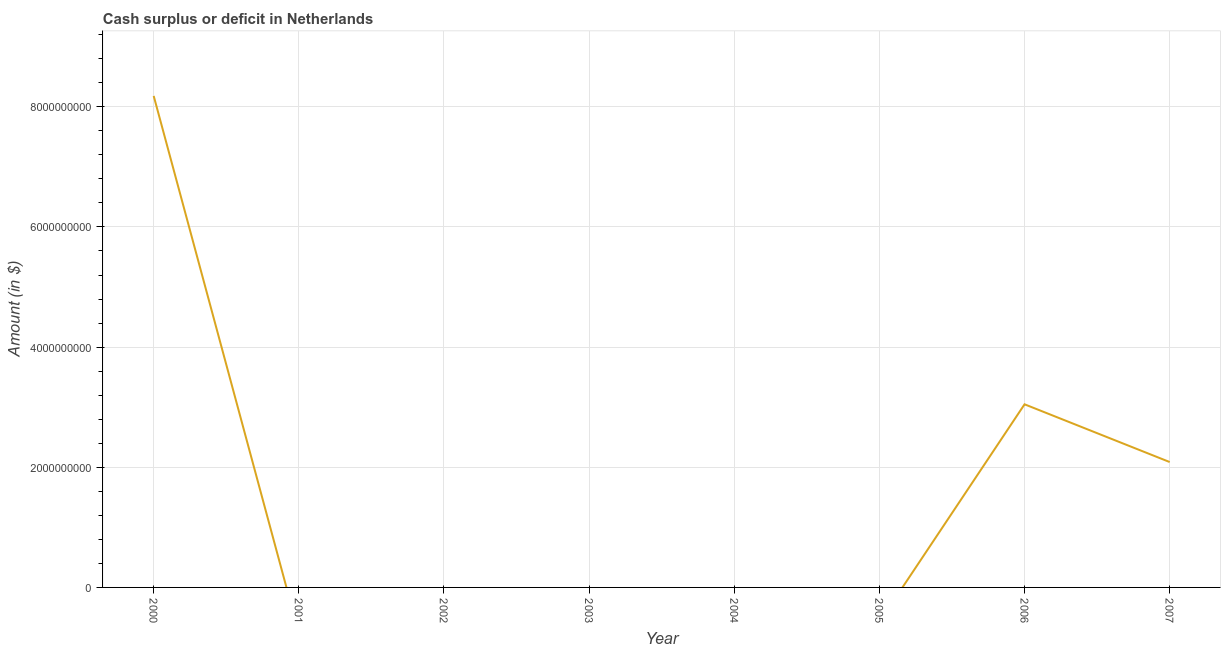Across all years, what is the maximum cash surplus or deficit?
Provide a short and direct response. 8.18e+09. In which year was the cash surplus or deficit maximum?
Offer a terse response. 2000. What is the sum of the cash surplus or deficit?
Keep it short and to the point. 1.33e+1. What is the average cash surplus or deficit per year?
Your response must be concise. 1.66e+09. In how many years, is the cash surplus or deficit greater than 400000000 $?
Your answer should be compact. 3. What is the ratio of the cash surplus or deficit in 2000 to that in 2007?
Provide a short and direct response. 3.92. Is the difference between the cash surplus or deficit in 2006 and 2007 greater than the difference between any two years?
Your answer should be very brief. No. What is the difference between the highest and the second highest cash surplus or deficit?
Make the answer very short. 5.13e+09. What is the difference between the highest and the lowest cash surplus or deficit?
Offer a terse response. 8.18e+09. Does the cash surplus or deficit monotonically increase over the years?
Make the answer very short. No. How many lines are there?
Your answer should be very brief. 1. How many years are there in the graph?
Provide a succinct answer. 8. What is the difference between two consecutive major ticks on the Y-axis?
Ensure brevity in your answer.  2.00e+09. Are the values on the major ticks of Y-axis written in scientific E-notation?
Your answer should be compact. No. What is the title of the graph?
Your answer should be compact. Cash surplus or deficit in Netherlands. What is the label or title of the Y-axis?
Give a very brief answer. Amount (in $). What is the Amount (in $) of 2000?
Provide a succinct answer. 8.18e+09. What is the Amount (in $) in 2001?
Offer a terse response. 0. What is the Amount (in $) of 2005?
Provide a short and direct response. 0. What is the Amount (in $) of 2006?
Your answer should be compact. 3.05e+09. What is the Amount (in $) in 2007?
Provide a succinct answer. 2.09e+09. What is the difference between the Amount (in $) in 2000 and 2006?
Your answer should be very brief. 5.13e+09. What is the difference between the Amount (in $) in 2000 and 2007?
Make the answer very short. 6.09e+09. What is the difference between the Amount (in $) in 2006 and 2007?
Make the answer very short. 9.61e+08. What is the ratio of the Amount (in $) in 2000 to that in 2006?
Offer a very short reply. 2.68. What is the ratio of the Amount (in $) in 2000 to that in 2007?
Offer a very short reply. 3.92. What is the ratio of the Amount (in $) in 2006 to that in 2007?
Your response must be concise. 1.46. 